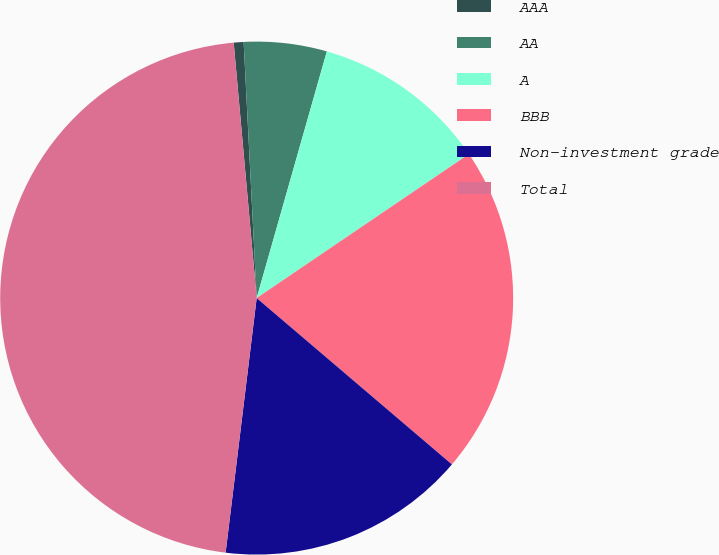Convert chart. <chart><loc_0><loc_0><loc_500><loc_500><pie_chart><fcel>AAA<fcel>AA<fcel>A<fcel>BBB<fcel>Non-investment grade<fcel>Total<nl><fcel>0.62%<fcel>5.22%<fcel>11.1%<fcel>20.72%<fcel>15.7%<fcel>46.64%<nl></chart> 